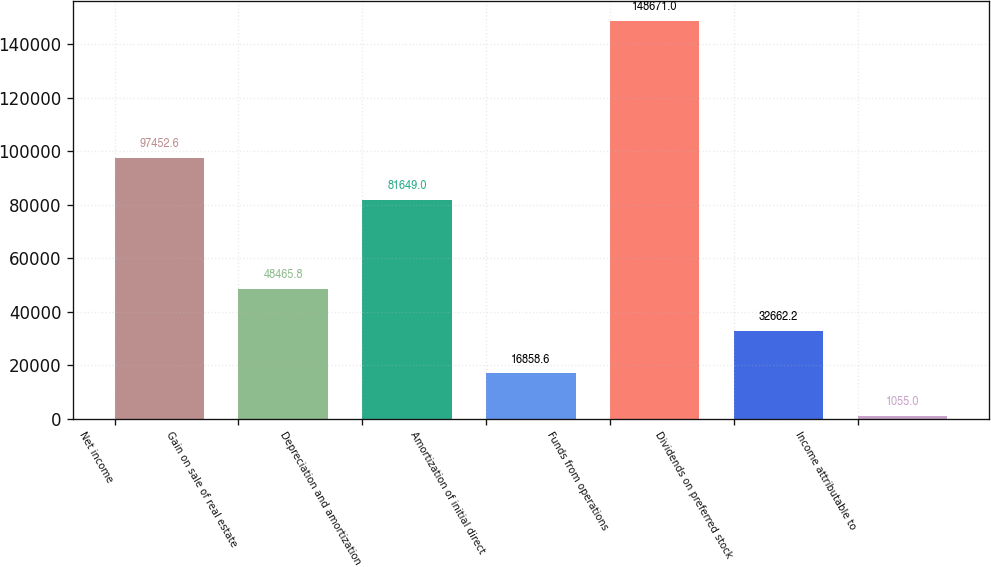Convert chart to OTSL. <chart><loc_0><loc_0><loc_500><loc_500><bar_chart><fcel>Net income<fcel>Gain on sale of real estate<fcel>Depreciation and amortization<fcel>Amortization of initial direct<fcel>Funds from operations<fcel>Dividends on preferred stock<fcel>Income attributable to<nl><fcel>97452.6<fcel>48465.8<fcel>81649<fcel>16858.6<fcel>148671<fcel>32662.2<fcel>1055<nl></chart> 